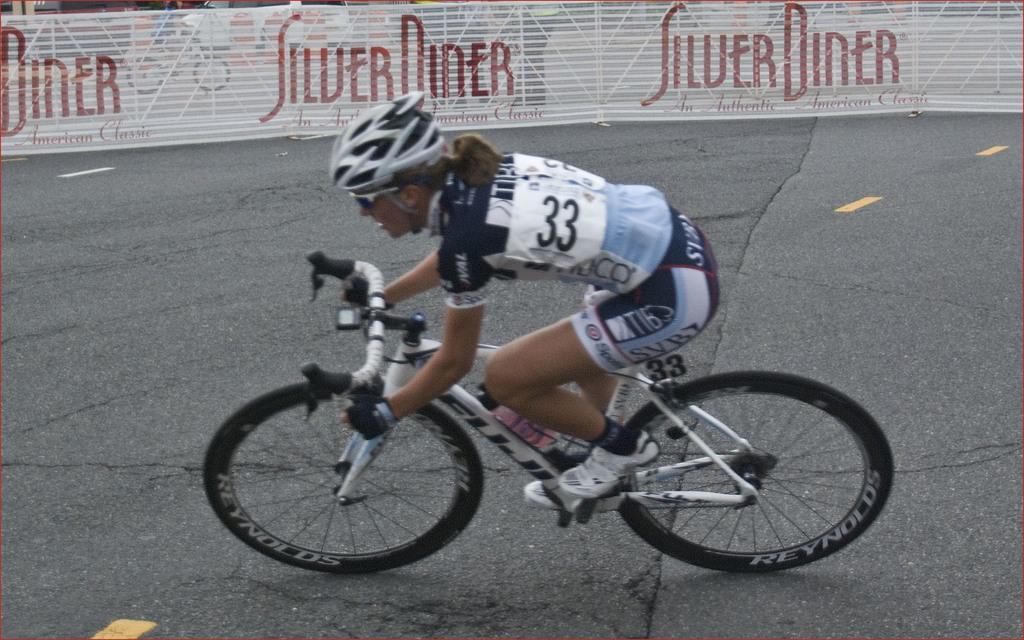Describe this image in one or two sentences. In the image there is a lady in sports dress riding bicycle on the road, in the back there is fence. 